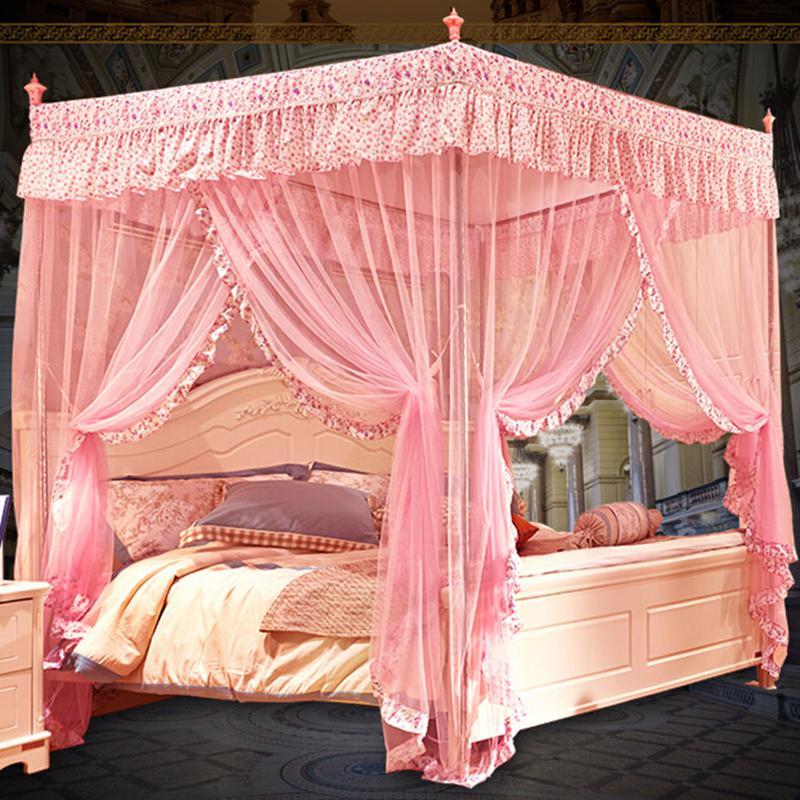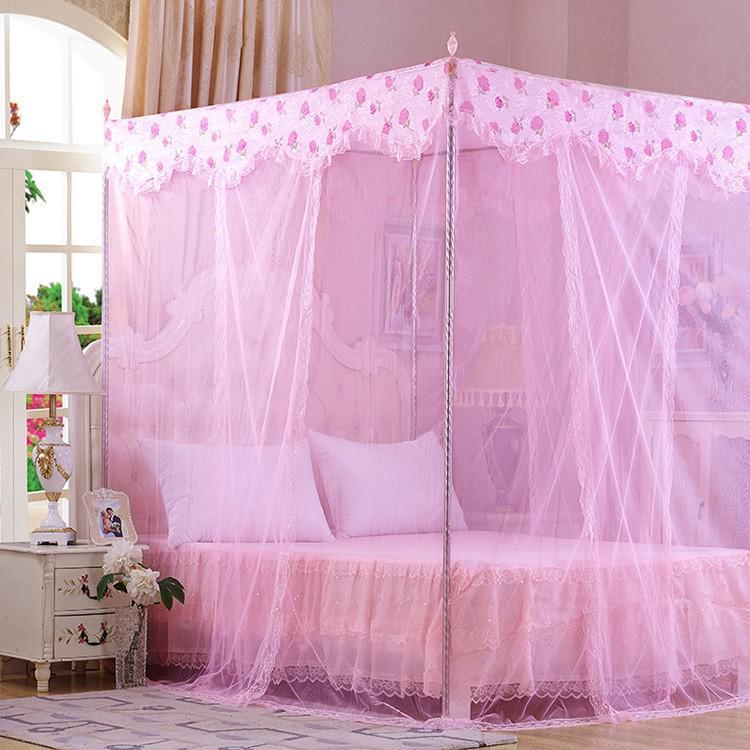The first image is the image on the left, the second image is the image on the right. Examine the images to the left and right. Is the description "The image on the right contains a bed set with a purple net canopy." accurate? Answer yes or no. Yes. 